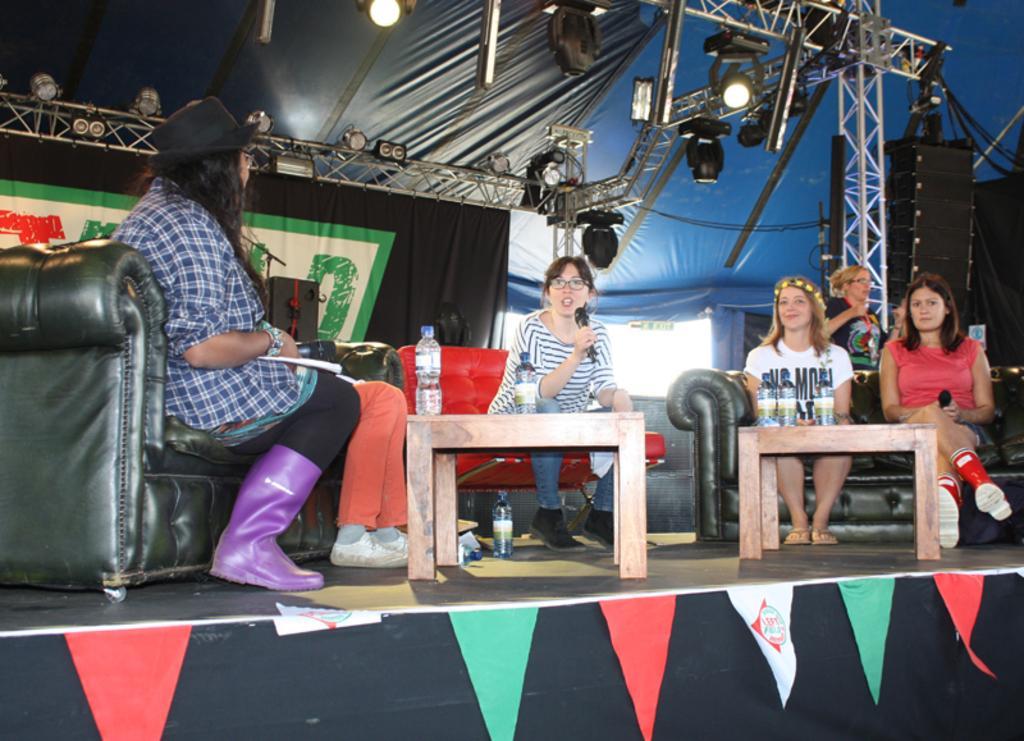How would you summarize this image in a sentence or two? In this picture there are group of girls those who are sitting on the stage and there are two tables in between them, there is a lady who is sitting at the center of the image and she is saying something in the mic and there are spotlights above the area of the image. 